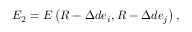<formula> <loc_0><loc_0><loc_500><loc_500>E _ { 2 } = E \left ( R - \Delta d e _ { i } , R - \Delta d e _ { j } \right ) ,</formula> 